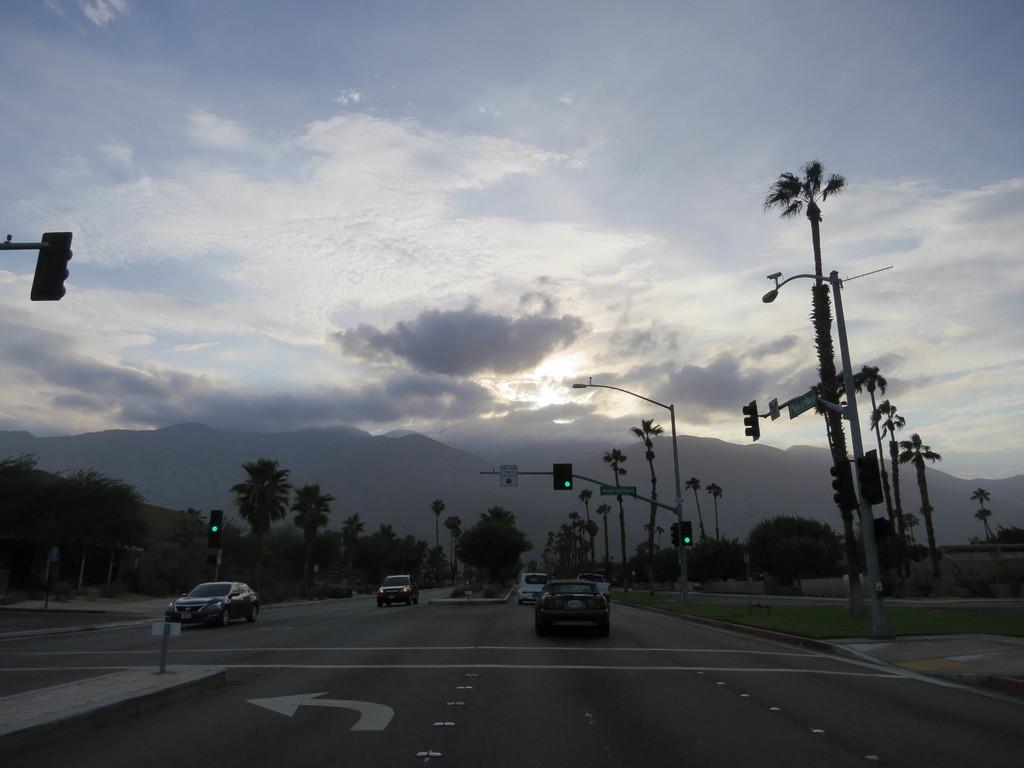Can you describe this image briefly? In this image at the bottom there are some vehicles on the road, on the right side and left side there are some trees, poles, and traffic signals. In the background there are some mountains, at the top of the image there is sky. 